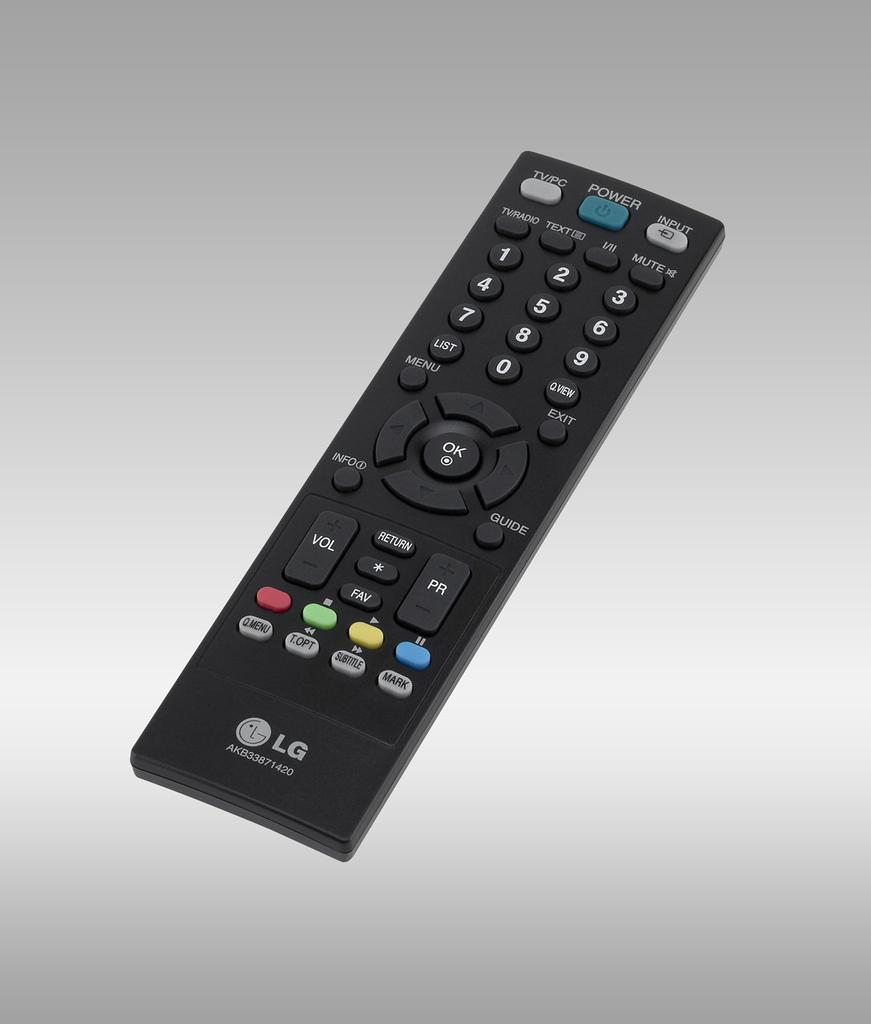<image>
Summarize the visual content of the image. Remote Control by LG that with the model number : AKB33871420. 